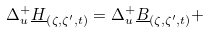Convert formula to latex. <formula><loc_0><loc_0><loc_500><loc_500>\Delta _ { u } ^ { + } \underline { H } _ { \left ( \zeta , \zeta ^ { \prime } , t \right ) } = \Delta _ { u } ^ { + } \underline { B } _ { \left ( \zeta , \zeta ^ { \prime } , t \right ) } +</formula> 